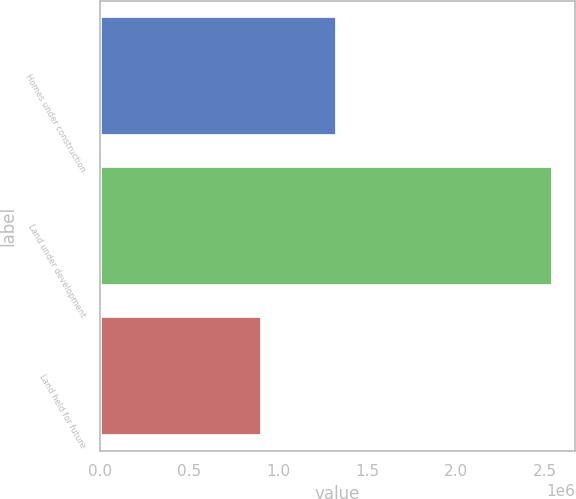Convert chart. <chart><loc_0><loc_0><loc_500><loc_500><bar_chart><fcel>Homes under construction<fcel>Land under development<fcel>Land held for future<nl><fcel>1.33162e+06<fcel>2.54183e+06<fcel>908366<nl></chart> 